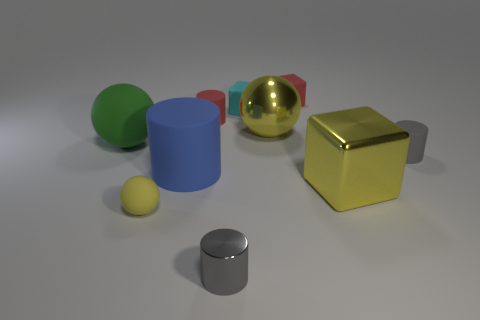How many objects are either metal cylinders or large matte balls?
Offer a very short reply. 2. What size is the shiny ball that is the same color as the large block?
Keep it short and to the point. Large. Are there fewer small red matte things than gray matte balls?
Provide a succinct answer. No. The blue cylinder that is made of the same material as the red block is what size?
Offer a very short reply. Large. How big is the red cylinder?
Your answer should be very brief. Small. There is a tiny metal object; what shape is it?
Provide a short and direct response. Cylinder. Is the color of the ball that is on the right side of the tiny cyan block the same as the tiny matte ball?
Make the answer very short. Yes. There is a green rubber object that is the same shape as the tiny yellow thing; what size is it?
Ensure brevity in your answer.  Large. Is there any other thing that has the same material as the cyan block?
Your answer should be very brief. Yes. Are there any tiny red things that are in front of the tiny red rubber object behind the tiny cylinder that is on the left side of the small shiny thing?
Provide a short and direct response. Yes. 